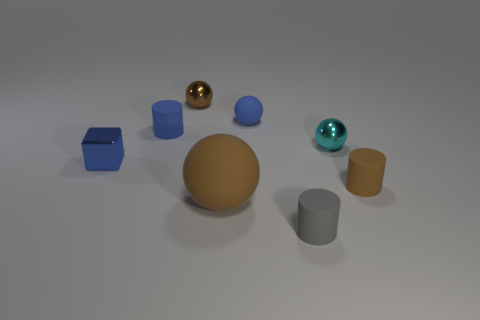Subtract all brown metal things. Subtract all tiny matte cylinders. How many objects are left? 4 Add 3 tiny blue rubber spheres. How many tiny blue rubber spheres are left? 4 Add 8 tiny blue shiny things. How many tiny blue shiny things exist? 9 Add 1 tiny yellow metal balls. How many objects exist? 9 Subtract all brown balls. How many balls are left? 2 Subtract all large brown matte balls. How many balls are left? 3 Subtract 0 red cylinders. How many objects are left? 8 Subtract all cylinders. How many objects are left? 5 Subtract 2 spheres. How many spheres are left? 2 Subtract all yellow cylinders. Subtract all gray blocks. How many cylinders are left? 3 